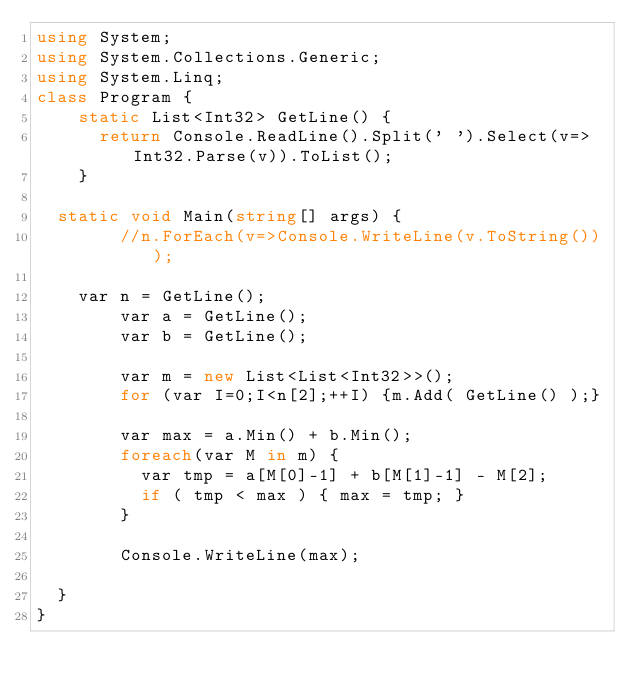<code> <loc_0><loc_0><loc_500><loc_500><_C#_>using System;
using System.Collections.Generic;
using System.Linq;
class Program {
  	static List<Int32> GetLine() {
    	return Console.ReadLine().Split(' ').Select(v=>Int32.Parse(v)).ToList();
    }
  
	static void Main(string[] args) {
      	//n.ForEach(v=>Console.WriteLine(v.ToString()));
      
		var n = GetLine();
      	var a = GetLine();
      	var b = GetLine();
      
      	var m = new List<List<Int32>>();
      	for (var I=0;I<n[2];++I) {m.Add( GetLine() );}
      	
      	var max = a.Min() + b.Min();
      	foreach(var M in m) {
          var tmp = a[M[0]-1] + b[M[1]-1] - M[2];
          if ( tmp < max ) { max = tmp; }
        }	
      	
      	Console.WriteLine(max);
      
	}
}</code> 